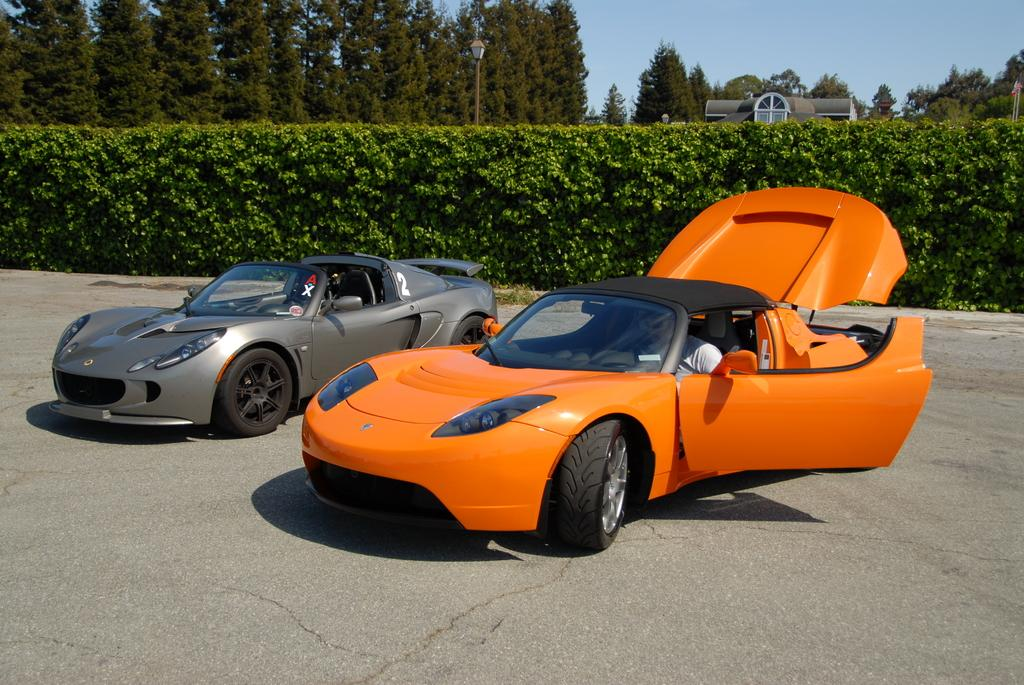What type of natural elements are present in the image? There are many trees and plants in the image. What type of structure can be seen in the image? There is a house in the image. What is the color of the sky in the image? The sky is blue in the image. What type of lighting fixture is present in the image? There is a lamp in the image. How many cars are visible in the image? There are two cars in the image. Is there anyone inside one of the cars? Yes, a person is sitting in one of the cars. How many boxes are stacked on top of the person sitting in the car? There are no boxes present in the image, so it is not possible to answer that question. 